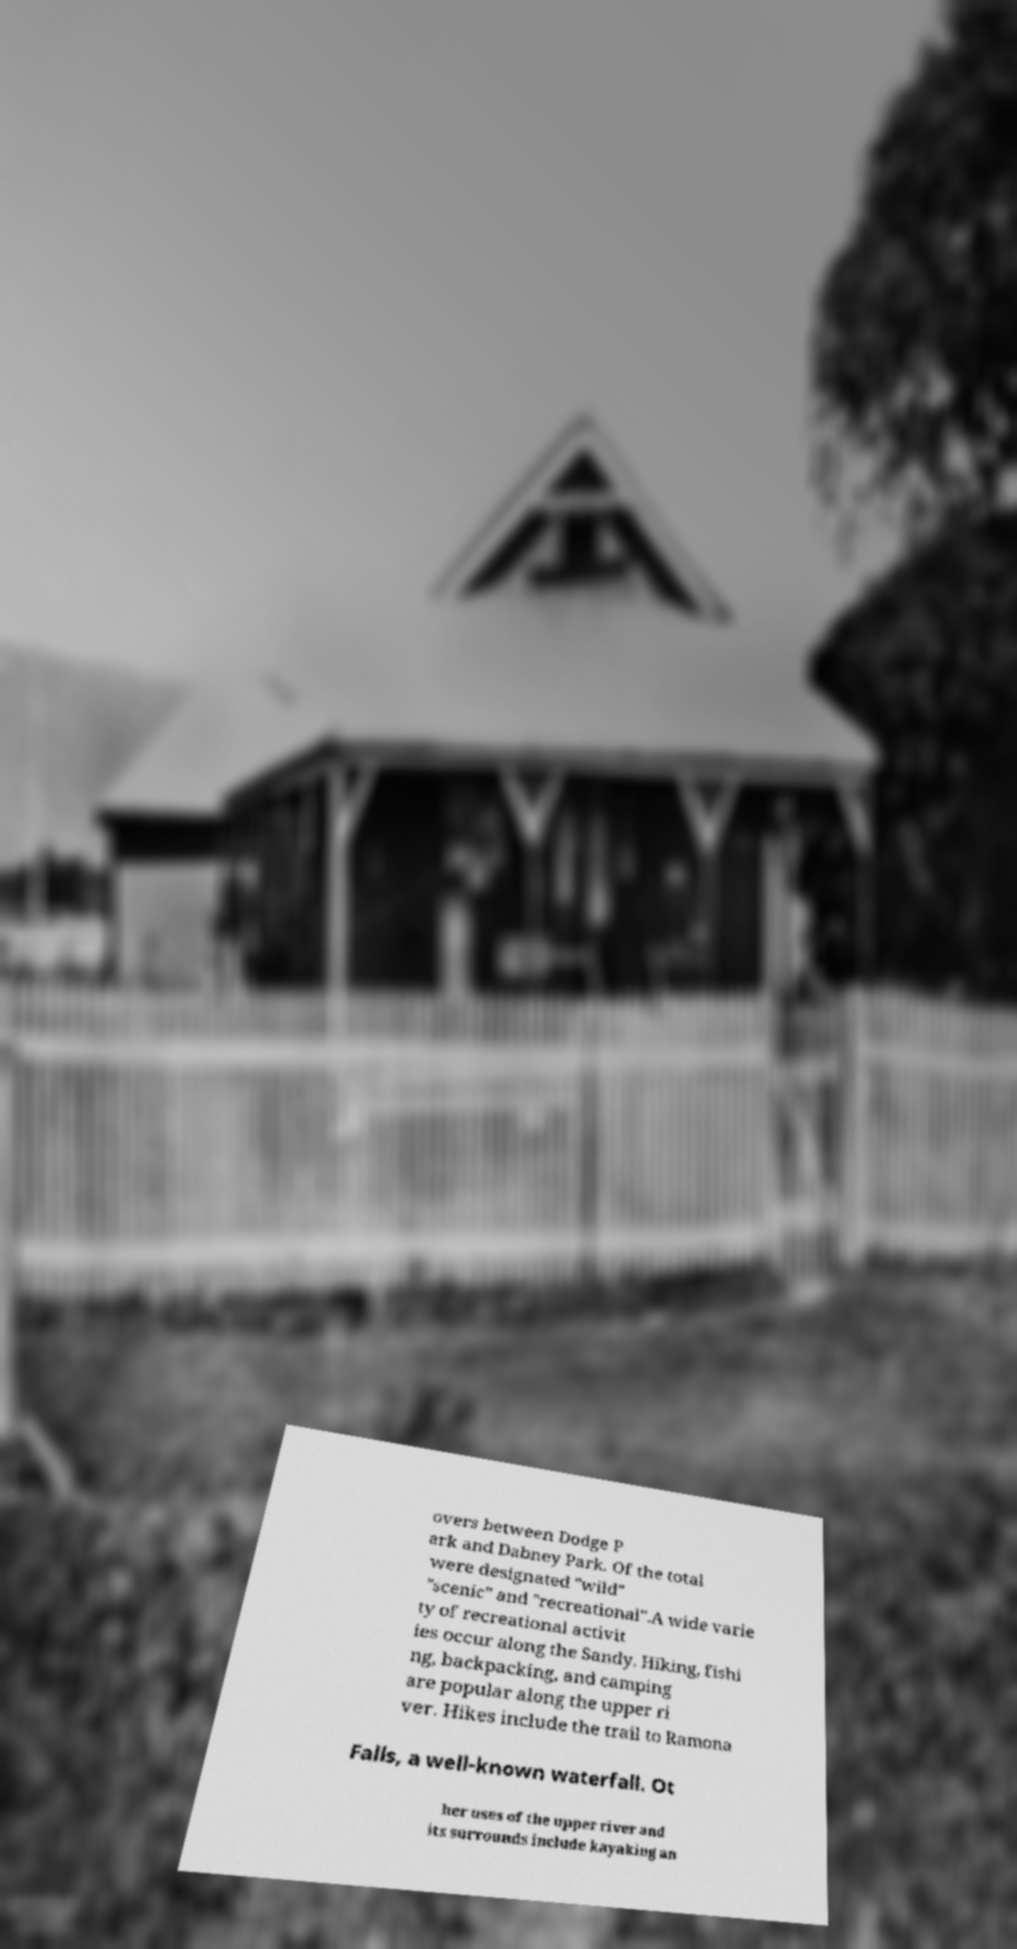Please identify and transcribe the text found in this image. overs between Dodge P ark and Dabney Park. Of the total were designated "wild" "scenic" and "recreational".A wide varie ty of recreational activit ies occur along the Sandy. Hiking, fishi ng, backpacking, and camping are popular along the upper ri ver. Hikes include the trail to Ramona Falls, a well-known waterfall. Ot her uses of the upper river and its surrounds include kayaking an 